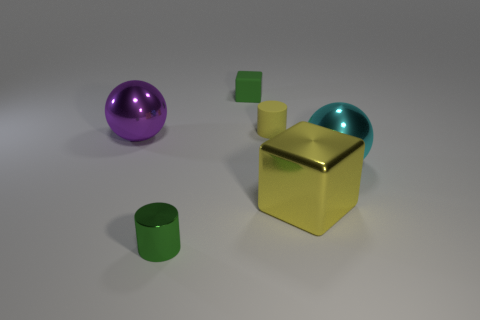Add 1 small brown objects. How many objects exist? 7 Subtract all spheres. How many objects are left? 4 Add 2 yellow metal things. How many yellow metal things exist? 3 Subtract 1 yellow blocks. How many objects are left? 5 Subtract all yellow balls. Subtract all blue blocks. How many balls are left? 2 Subtract all cyan shiny balls. Subtract all tiny green cylinders. How many objects are left? 4 Add 6 big purple objects. How many big purple objects are left? 7 